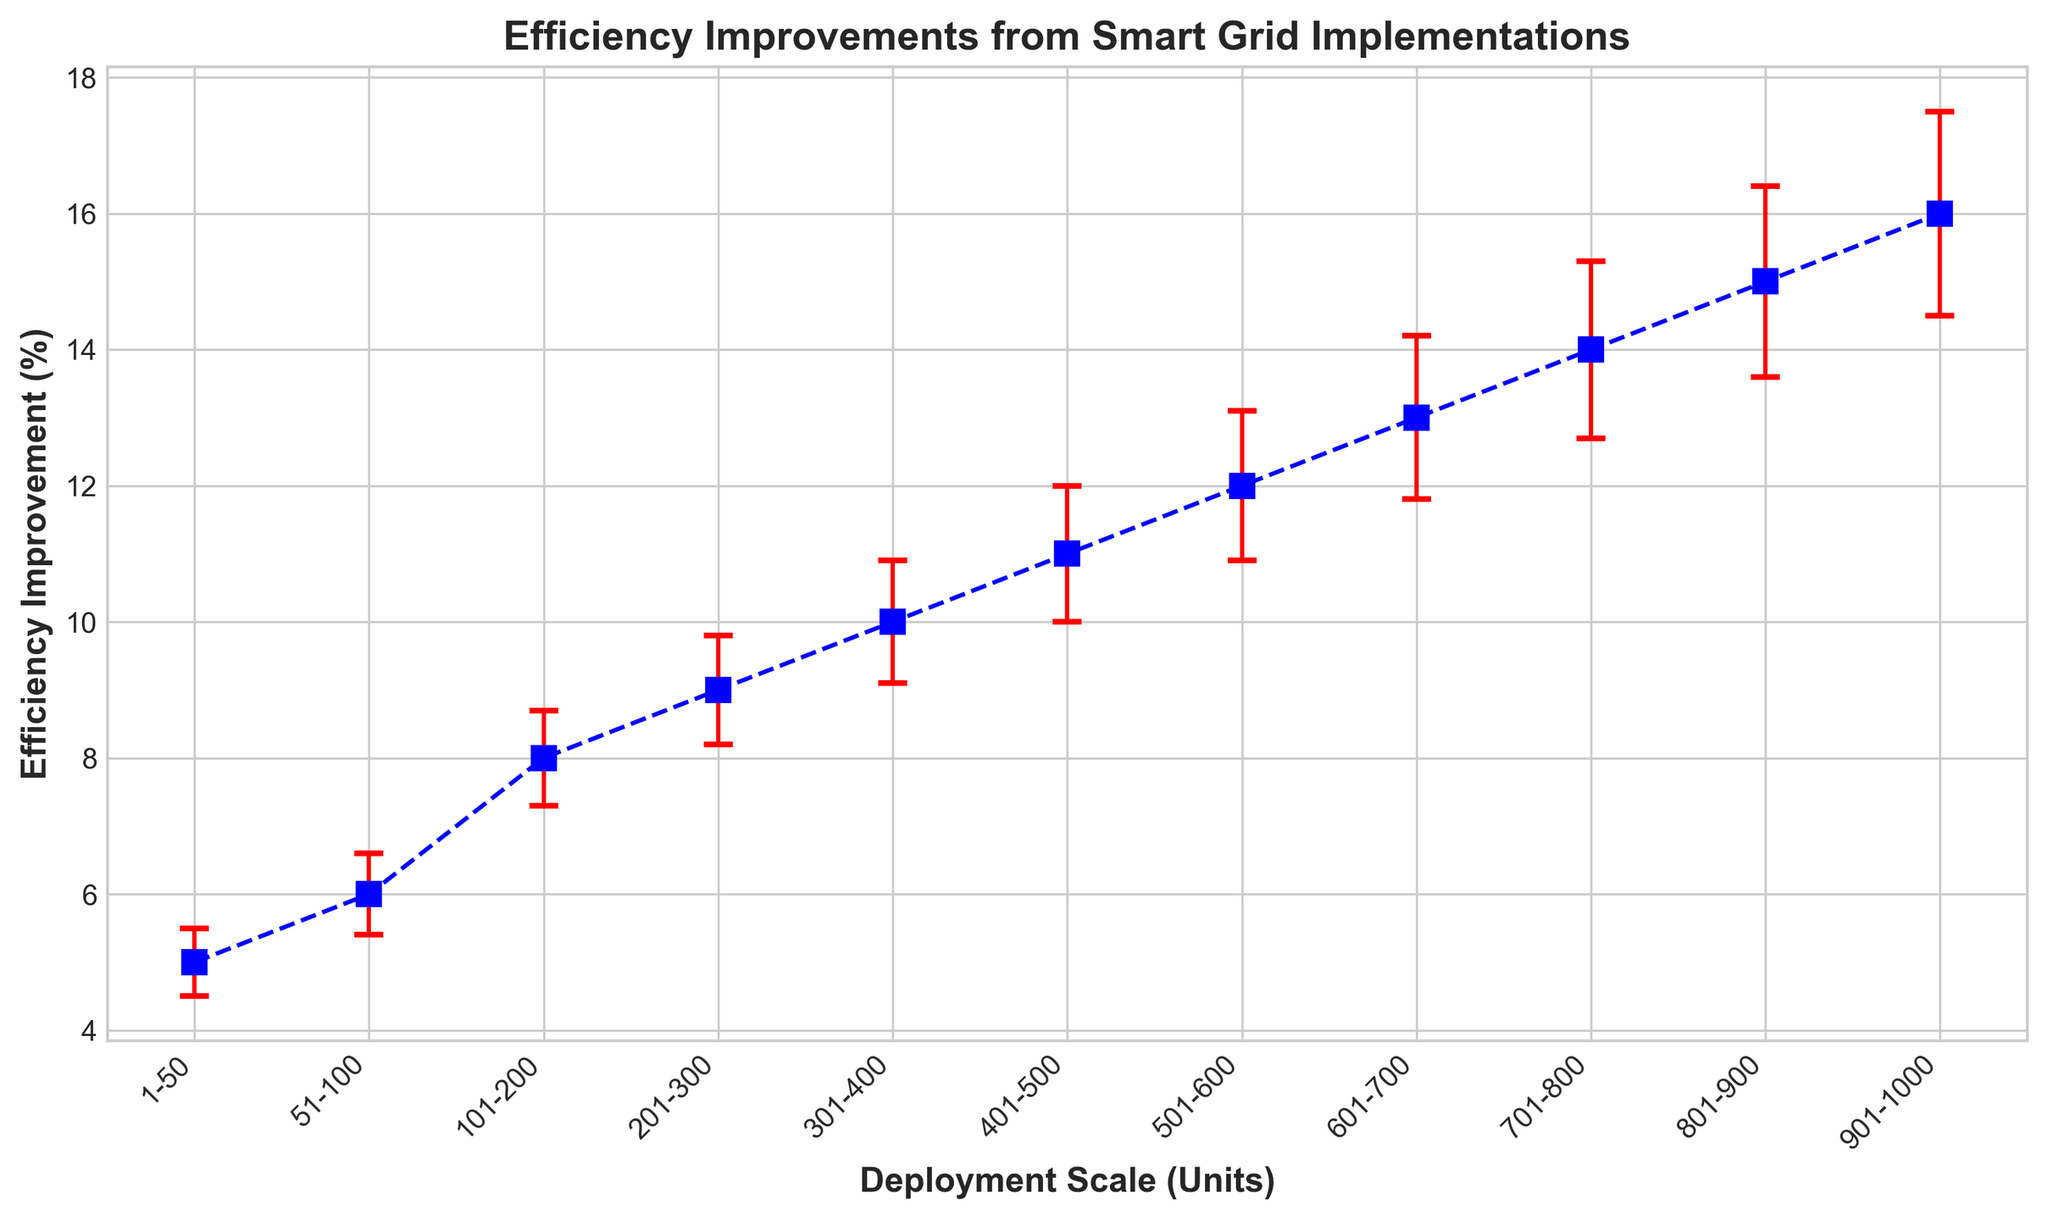What's the highest efficiency improvement achieved? The highest efficiency improvement is represented by the highest point on the y-axis of the chart. By looking at the values, we can see that the maximum efficiency improvement is 16%.
Answer: 16% Which deployment scale has the least efficiency improvement? The least efficiency improvement is shown at the lowest point on the y-axis of the chart, corresponding to the smallest y value. This points specifically to the 1-50 scale having an improvement of 5%.
Answer: 1-50 How does the error range change with increasing deployment scale? Observing the error bars on the chart, the error range increases as the deployment scale increases. This can be seen by the gradually enlarging vertical bars from left to right. For example, at the 1-50 scale, the error range is 0.5, but it increases to 1.5 at the 901-1000 scale.
Answer: It increases What is the efficiency improvement for the 401-500 scale and its corresponding error range? Look for the point labeled '401-500' on the x-axis and then identify the corresponding y value and its error bar. The efficiency improvement is 11% with an error range of 1%.
Answer: 11% with 1% Which two consecutive deployment scales show the largest increase in efficiency improvement? Examine the efficiency improvements between each consecutive pair of points. Observe that the increase from the 101-200 scale to the 201-300 scale shows an increase from 8% to 9%, which is the largest step between any two consecutive points on the graph.
Answer: 101-200 to 201-300 Compare the efficiency improvements for the 301-400 and 501-600 scales. Which one is higher? By referring to the chart, the efficiency improvement for the 301-400 scale is 10%, while for the 501-600 scale it is 12%. Thus, the 501-600 scale has a higher efficiency improvement than the 301-400 scale.
Answer: 501-600 scale What is the average efficiency improvement for deployment scales ranging from 1-50 to 301-400? The relevant efficiency improvements are 5%, 6%, 8%, 9%, and 10%. Summing these values gives 38. Dividing by the number of values (5) results in an average of 7.6%.
Answer: 7.6% At which deployment scale do error bars become equal to 1%? Locate the deployment scale where the height of the error bar is exactly 1%. This occurs at the 401-500 scale, as indicated by the error range data.
Answer: 401-500 Is there any deployment scale where the efficiency improvement is exactly double that of the 51-100 scale? The efficiency improvement for the 51-100 scale is 6%. Doubling this value results in 12%. The chart shows that the 501-600 scale has an efficiency improvement of 12%, thus fulfilling this condition.
Answer: 501-600 scale How much does the efficiency improve from a scale of 1-50 to 901-1000? The efficiency improvement for the 1-50 scale is 5%, and for the 901-1000 scale is 16%. Subtracting the smaller value from the larger gives an increase of 11%.
Answer: 11% 